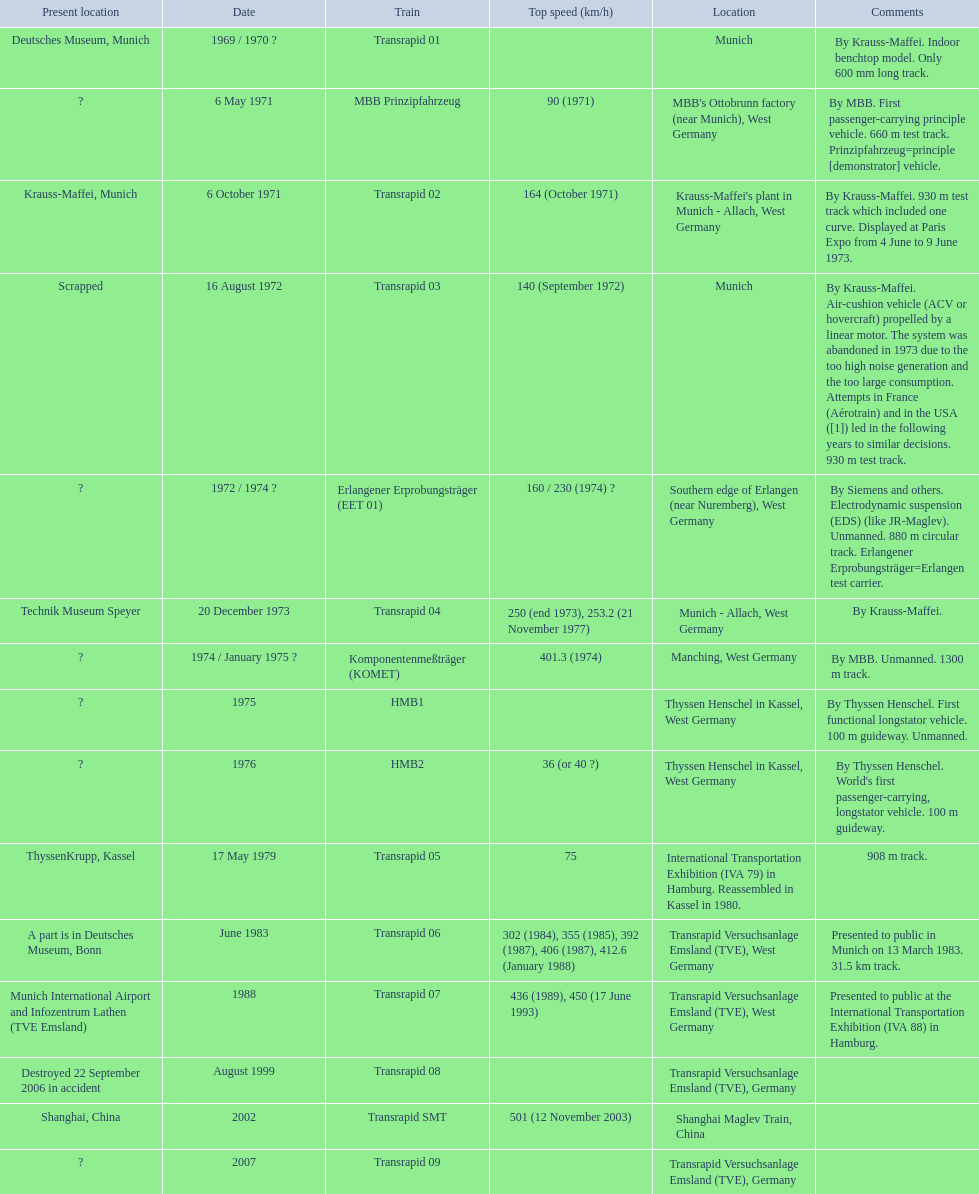What are the names of each transrapid train? Transrapid 01, MBB Prinzipfahrzeug, Transrapid 02, Transrapid 03, Erlangener Erprobungsträger (EET 01), Transrapid 04, Komponentenmeßträger (KOMET), HMB1, HMB2, Transrapid 05, Transrapid 06, Transrapid 07, Transrapid 08, Transrapid SMT, Transrapid 09. What are their listed top speeds? 90 (1971), 164 (October 1971), 140 (September 1972), 160 / 230 (1974) ?, 250 (end 1973), 253.2 (21 November 1977), 401.3 (1974), 36 (or 40 ?), 75, 302 (1984), 355 (1985), 392 (1987), 406 (1987), 412.6 (January 1988), 436 (1989), 450 (17 June 1993), 501 (12 November 2003). And which train operates at the fastest speed? Transrapid SMT. 